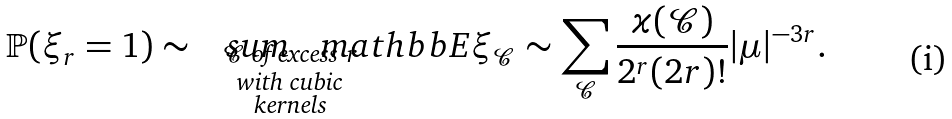Convert formula to latex. <formula><loc_0><loc_0><loc_500><loc_500>\mathbb { P } ( \xi _ { r } = 1 ) \sim \ \ \ s u m _ { \mathclap { \substack { \mathcal { C } \text { of excess } r \\ \text {with cubic} \\ \text {kernels} } } } \ \ \ m a t h b b { E } \xi _ { \mathcal { C } } \sim \sum _ { \mathcal { C } } \frac { \varkappa ( \mathcal { C } ) } { 2 ^ { r } ( 2 r ) ! } | \mu | ^ { - 3 r } .</formula> 